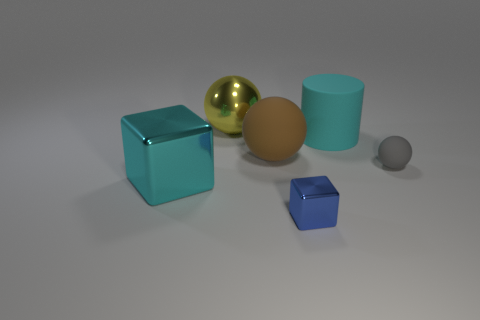How many matte things are brown things or cyan objects?
Provide a succinct answer. 2. The sphere that is both in front of the large yellow sphere and left of the large cyan cylinder is what color?
Make the answer very short. Brown. What number of large cyan rubber cylinders are right of the blue cube?
Give a very brief answer. 1. What is the small gray thing made of?
Provide a succinct answer. Rubber. There is a metallic block that is left of the shiny block in front of the big cyan object on the left side of the small cube; what is its color?
Your answer should be very brief. Cyan. How many red matte objects are the same size as the cyan rubber object?
Offer a terse response. 0. What color is the metallic cube left of the big yellow ball?
Ensure brevity in your answer.  Cyan. How many other objects are there of the same size as the yellow thing?
Offer a very short reply. 3. How big is the object that is both to the right of the large yellow shiny object and in front of the tiny gray sphere?
Your answer should be very brief. Small. There is a large cylinder; does it have the same color as the big object that is in front of the small rubber sphere?
Your response must be concise. Yes. 